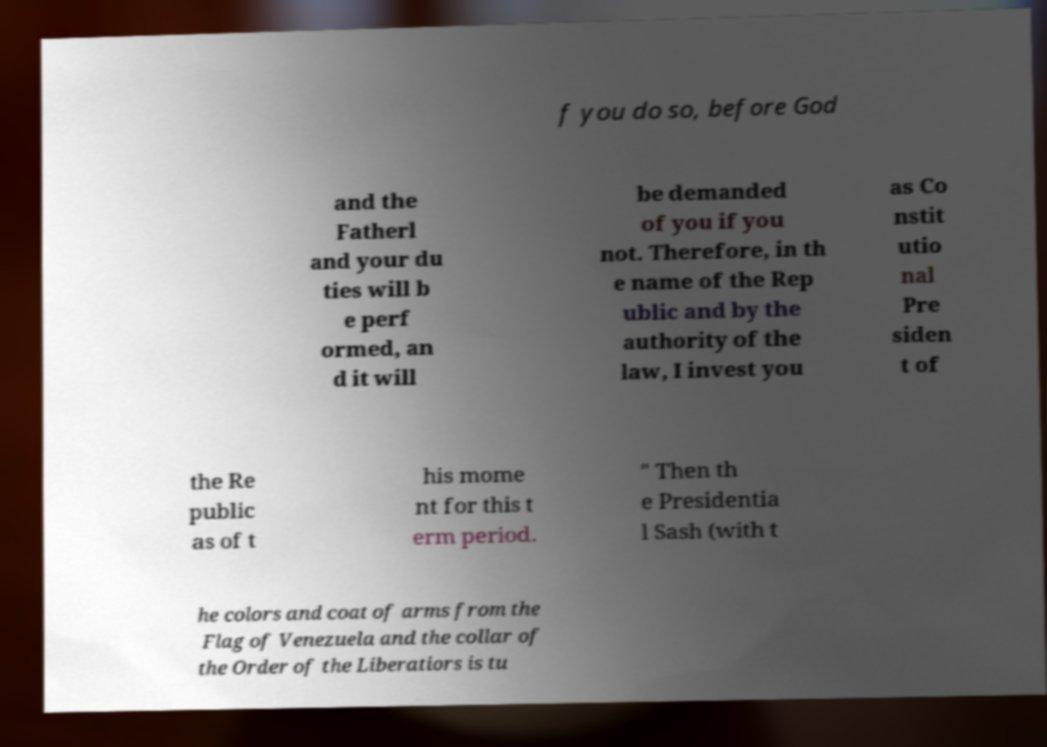Could you assist in decoding the text presented in this image and type it out clearly? f you do so, before God and the Fatherl and your du ties will b e perf ormed, an d it will be demanded of you if you not. Therefore, in th e name of the Rep ublic and by the authority of the law, I invest you as Co nstit utio nal Pre siden t of the Re public as of t his mome nt for this t erm period. " Then th e Presidentia l Sash (with t he colors and coat of arms from the Flag of Venezuela and the collar of the Order of the Liberatiors is tu 